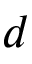Convert formula to latex. <formula><loc_0><loc_0><loc_500><loc_500>d</formula> 